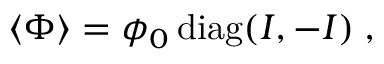<formula> <loc_0><loc_0><loc_500><loc_500>\langle \Phi \rangle = \phi _ { 0 } \, d i a g ( I , - I ) \, ,</formula> 